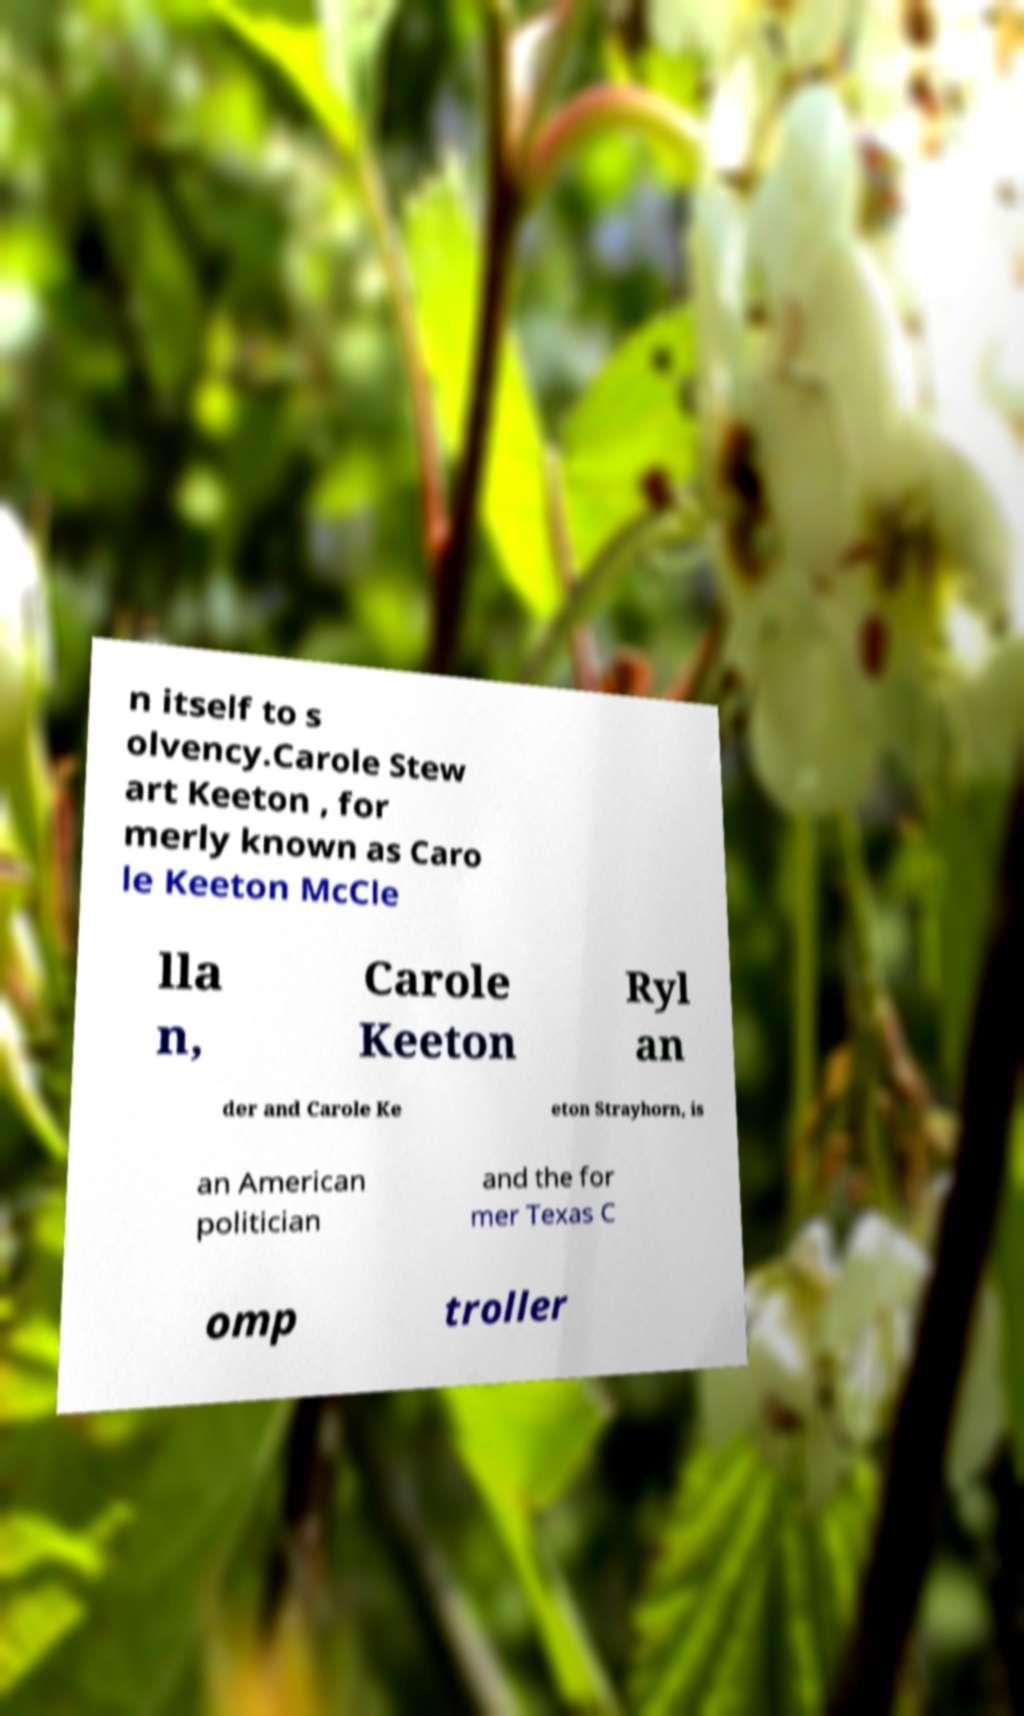What messages or text are displayed in this image? I need them in a readable, typed format. n itself to s olvency.Carole Stew art Keeton , for merly known as Caro le Keeton McCle lla n, Carole Keeton Ryl an der and Carole Ke eton Strayhorn, is an American politician and the for mer Texas C omp troller 